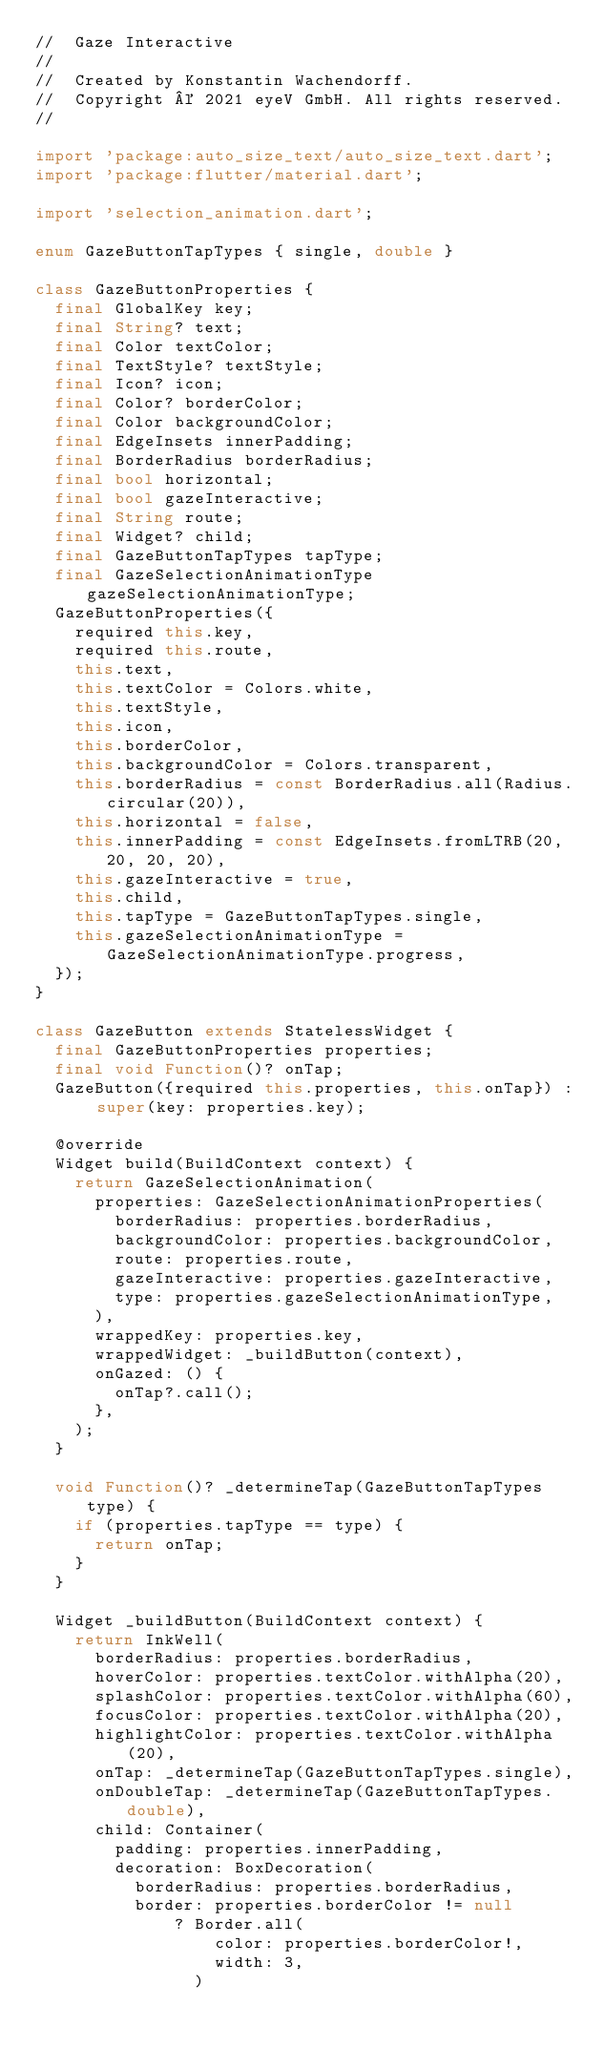<code> <loc_0><loc_0><loc_500><loc_500><_Dart_>//  Gaze Interactive
//
//  Created by Konstantin Wachendorff.
//  Copyright © 2021 eyeV GmbH. All rights reserved.
//

import 'package:auto_size_text/auto_size_text.dart';
import 'package:flutter/material.dart';

import 'selection_animation.dart';

enum GazeButtonTapTypes { single, double }

class GazeButtonProperties {
  final GlobalKey key;
  final String? text;
  final Color textColor;
  final TextStyle? textStyle;
  final Icon? icon;
  final Color? borderColor;
  final Color backgroundColor;
  final EdgeInsets innerPadding;
  final BorderRadius borderRadius;
  final bool horizontal;
  final bool gazeInteractive;
  final String route;
  final Widget? child;
  final GazeButtonTapTypes tapType;
  final GazeSelectionAnimationType gazeSelectionAnimationType;
  GazeButtonProperties({
    required this.key,
    required this.route,
    this.text,
    this.textColor = Colors.white,
    this.textStyle,
    this.icon,
    this.borderColor,
    this.backgroundColor = Colors.transparent,
    this.borderRadius = const BorderRadius.all(Radius.circular(20)),
    this.horizontal = false,
    this.innerPadding = const EdgeInsets.fromLTRB(20, 20, 20, 20),
    this.gazeInteractive = true,
    this.child,
    this.tapType = GazeButtonTapTypes.single,
    this.gazeSelectionAnimationType = GazeSelectionAnimationType.progress,
  });
}

class GazeButton extends StatelessWidget {
  final GazeButtonProperties properties;
  final void Function()? onTap;
  GazeButton({required this.properties, this.onTap}) : super(key: properties.key);

  @override
  Widget build(BuildContext context) {
    return GazeSelectionAnimation(
      properties: GazeSelectionAnimationProperties(
        borderRadius: properties.borderRadius,
        backgroundColor: properties.backgroundColor,
        route: properties.route,
        gazeInteractive: properties.gazeInteractive,
        type: properties.gazeSelectionAnimationType,
      ),
      wrappedKey: properties.key,
      wrappedWidget: _buildButton(context),
      onGazed: () {
        onTap?.call();
      },
    );
  }

  void Function()? _determineTap(GazeButtonTapTypes type) {
    if (properties.tapType == type) {
      return onTap;
    }
  }

  Widget _buildButton(BuildContext context) {
    return InkWell(
      borderRadius: properties.borderRadius,
      hoverColor: properties.textColor.withAlpha(20),
      splashColor: properties.textColor.withAlpha(60),
      focusColor: properties.textColor.withAlpha(20),
      highlightColor: properties.textColor.withAlpha(20),
      onTap: _determineTap(GazeButtonTapTypes.single),
      onDoubleTap: _determineTap(GazeButtonTapTypes.double),
      child: Container(
        padding: properties.innerPadding,
        decoration: BoxDecoration(
          borderRadius: properties.borderRadius,
          border: properties.borderColor != null
              ? Border.all(
                  color: properties.borderColor!,
                  width: 3,
                )</code> 